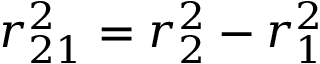<formula> <loc_0><loc_0><loc_500><loc_500>r _ { 2 1 } ^ { 2 } = r _ { 2 } ^ { 2 } - r _ { 1 } ^ { 2 }</formula> 